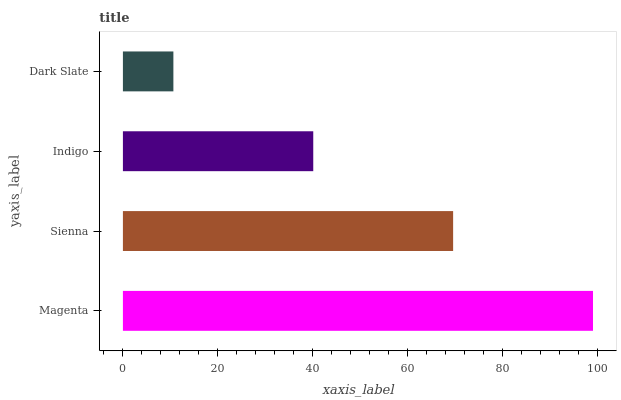Is Dark Slate the minimum?
Answer yes or no. Yes. Is Magenta the maximum?
Answer yes or no. Yes. Is Sienna the minimum?
Answer yes or no. No. Is Sienna the maximum?
Answer yes or no. No. Is Magenta greater than Sienna?
Answer yes or no. Yes. Is Sienna less than Magenta?
Answer yes or no. Yes. Is Sienna greater than Magenta?
Answer yes or no. No. Is Magenta less than Sienna?
Answer yes or no. No. Is Sienna the high median?
Answer yes or no. Yes. Is Indigo the low median?
Answer yes or no. Yes. Is Dark Slate the high median?
Answer yes or no. No. Is Sienna the low median?
Answer yes or no. No. 